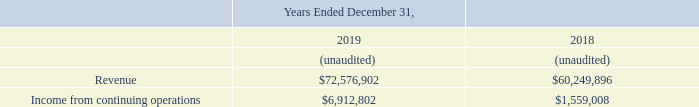Pro forma consolidated results of operations
The following unaudited pro forma financial information presents combined results of operations for each of the periods presented as if the acquisitions of MOI and GP had been completed on January 1, 2018. The pro forma information includes adjustments to depreciation expense for property and equipment acquired and amortization expense for the intangible assets acquired and the elimination of transaction expenses recognized in each period. Transaction-related expenses associated with the acquisition and excluded from pro forma income from continuing operations were $1.0 million for the year ended December 31, 2019. There were no transaction-related expenses associated with the acquisition for the year ended December 31, 2018. The pro forma data are for informational purposes only and are not necessarily indicative of the consolidated results of operations or the combined business had the acquisitions of MOI and GP occurred on January 1, 2018, or the results of future operations of the combined business. For instance, planned or expected operational synergies following the acquisition are not reflected in the pro forma information. Consequently, actual results will differ from the unaudited pro forma information presented below.
Was there any transaction-related expenses associated with the acquisition for the year ended December 31, 2018? There were no transaction-related expenses associated with the acquisition for the year ended december 31, 2018. What is the change in Revenue from December 31, 2018 and 2019? 72,576,902-60,249,896
Answer: 12327006. What is the average Revenue for December 31, 2018 and 2019? (72,576,902+60,249,896) / 2
Answer: 66413399. In which year was Revenue less than 65,000,000? Locate and analyze revenue in row 4
answer: 2018. What was the Income from continuing operations in 2019 and 2018 respectively? $6,912,802, $1,559,008. What was the revenue in 2019? $72,576,902. 